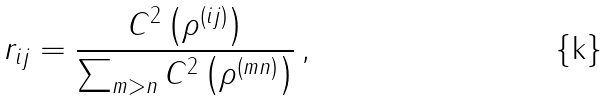<formula> <loc_0><loc_0><loc_500><loc_500>r _ { i j } = \frac { C ^ { 2 } \left ( \rho ^ { ( i j ) } \right ) } { \sum _ { m > n } C ^ { 2 } \left ( \rho ^ { ( m n ) } \right ) } \, ,</formula> 